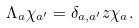Convert formula to latex. <formula><loc_0><loc_0><loc_500><loc_500>\Lambda _ { a } \chi _ { a ^ { \prime } } = \delta _ { a , a ^ { \prime } } z \chi _ { a } .</formula> 